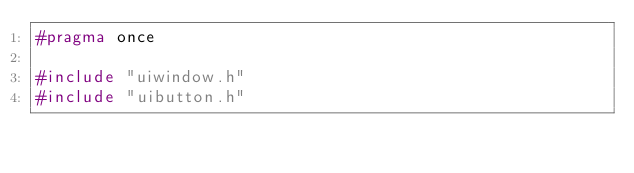Convert code to text. <code><loc_0><loc_0><loc_500><loc_500><_C_>#pragma once

#include "uiwindow.h"
#include "uibutton.h"</code> 